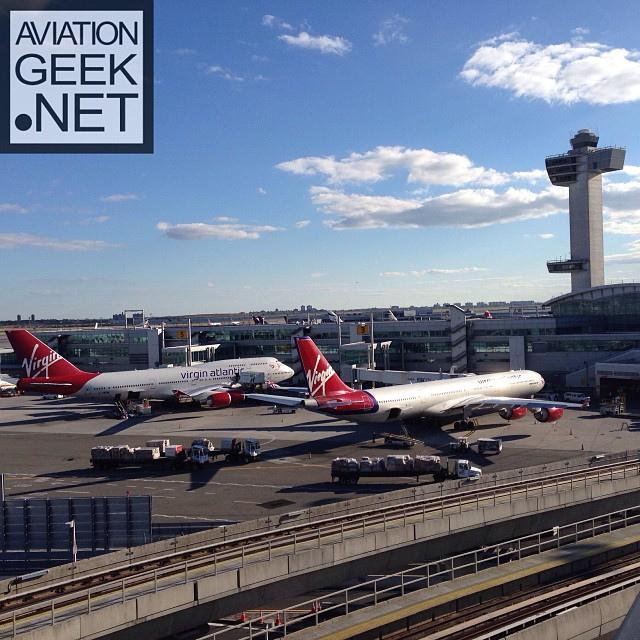What state has a name closest to the name that is found on the vehicle? Please explain your reasoning. virginia. A simple comparison reveals this fact. that said, virgin atlantic isn't headquartered there. 